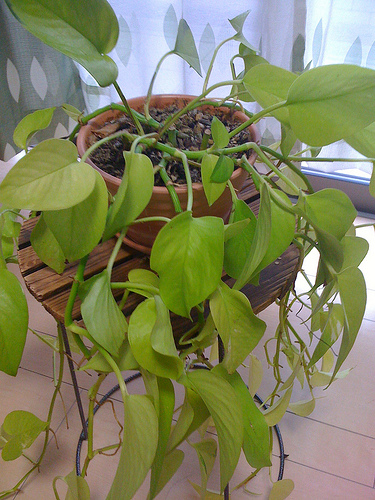<image>
Is the plant next to the table? No. The plant is not positioned next to the table. They are located in different areas of the scene. 